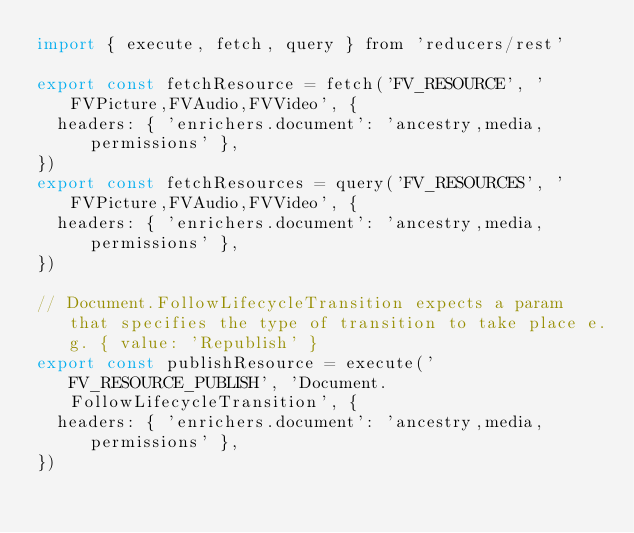Convert code to text. <code><loc_0><loc_0><loc_500><loc_500><_JavaScript_>import { execute, fetch, query } from 'reducers/rest'

export const fetchResource = fetch('FV_RESOURCE', 'FVPicture,FVAudio,FVVideo', {
  headers: { 'enrichers.document': 'ancestry,media,permissions' },
})
export const fetchResources = query('FV_RESOURCES', 'FVPicture,FVAudio,FVVideo', {
  headers: { 'enrichers.document': 'ancestry,media,permissions' },
})

// Document.FollowLifecycleTransition expects a param that specifies the type of transition to take place e.g. { value: 'Republish' }
export const publishResource = execute('FV_RESOURCE_PUBLISH', 'Document.FollowLifecycleTransition', {
  headers: { 'enrichers.document': 'ancestry,media,permissions' },
})
</code> 